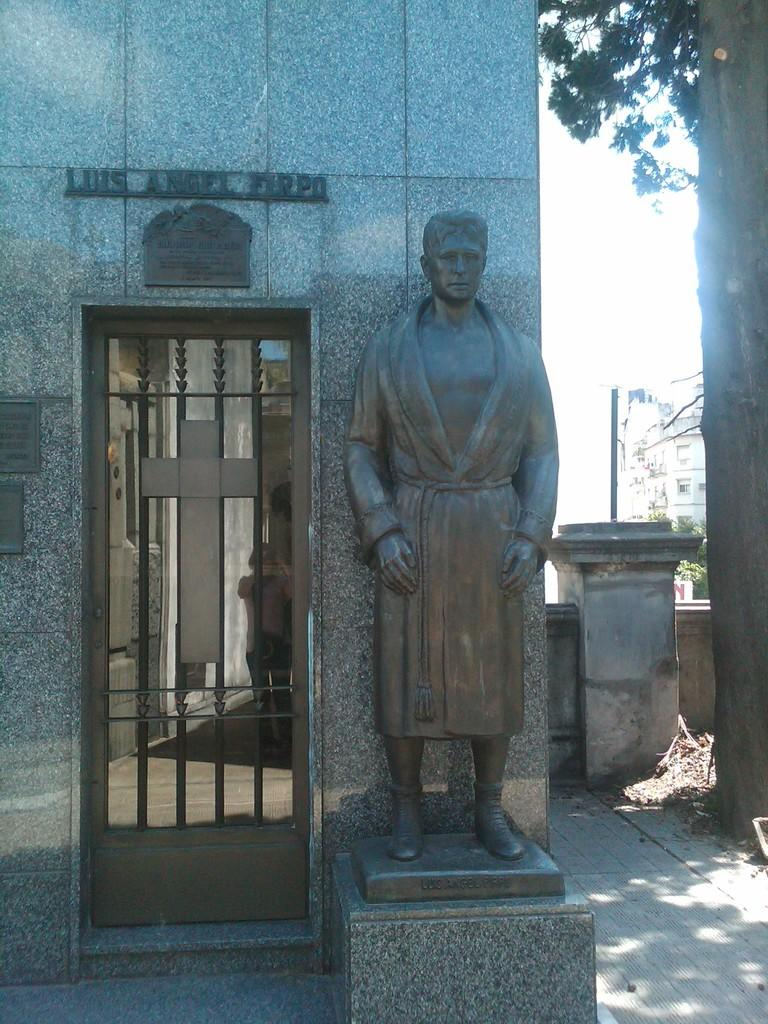What is the main subject on the platform in the image? There is a statue on a platform in the image. What religious symbol can be seen on a door in the image? There is a cross on a door in the image. What type of structures can be seen in the image? There are walls visible in the image. What type of natural elements can be seen in the image? There are trees in the image. What other objects are present in the image? There are some objects in the image. What can be seen in the background of the image? There is a building and the sky visible in the background of the image. Can you tell me how many credit cards are visible in the image? There are no credit cards present in the image. What type of office furniture can be seen in the image? There is no office furniture present in the image. 